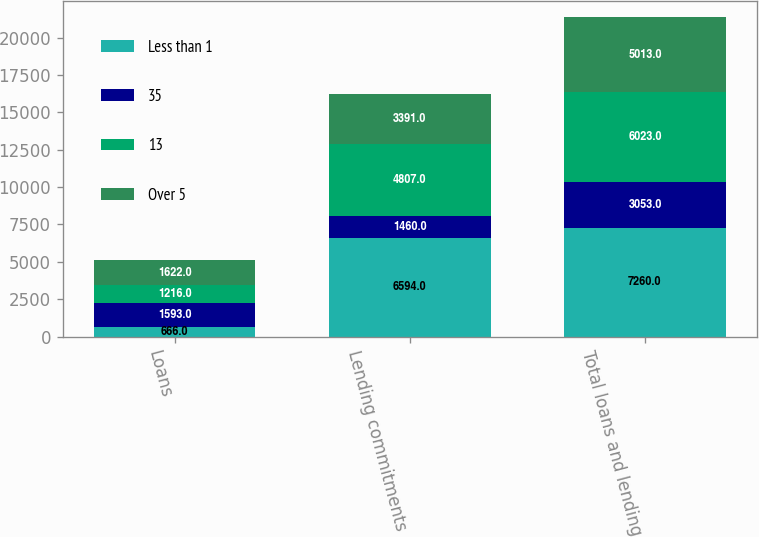<chart> <loc_0><loc_0><loc_500><loc_500><stacked_bar_chart><ecel><fcel>Loans<fcel>Lending commitments<fcel>Total loans and lending<nl><fcel>Less than 1<fcel>666<fcel>6594<fcel>7260<nl><fcel>35<fcel>1593<fcel>1460<fcel>3053<nl><fcel>13<fcel>1216<fcel>4807<fcel>6023<nl><fcel>Over 5<fcel>1622<fcel>3391<fcel>5013<nl></chart> 